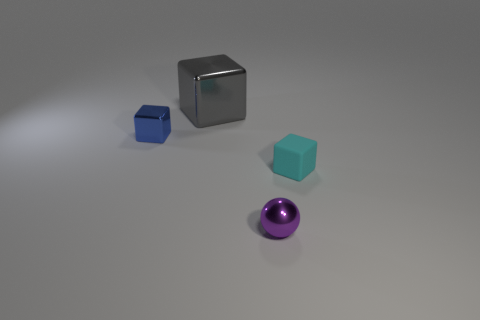What size is the blue block that is made of the same material as the small ball?
Your response must be concise. Small. Are there fewer gray objects than objects?
Make the answer very short. Yes. What is the small cube that is to the right of the small thing left of the big block left of the cyan matte thing made of?
Give a very brief answer. Rubber. Do the tiny block that is behind the tiny cyan object and the tiny cube that is on the right side of the blue metallic object have the same material?
Offer a terse response. No. What size is the object that is in front of the large cube and behind the matte thing?
Provide a short and direct response. Small. There is a cyan cube that is the same size as the blue block; what material is it?
Make the answer very short. Rubber. There is a cube in front of the tiny metallic object that is behind the cyan matte cube; how many metallic things are on the right side of it?
Keep it short and to the point. 0. Does the tiny metallic sphere on the right side of the blue object have the same color as the block to the right of the large gray object?
Your answer should be very brief. No. What is the color of the object that is both behind the purple metal sphere and in front of the tiny blue metal cube?
Your response must be concise. Cyan. What number of cyan metal cylinders have the same size as the sphere?
Offer a terse response. 0. 